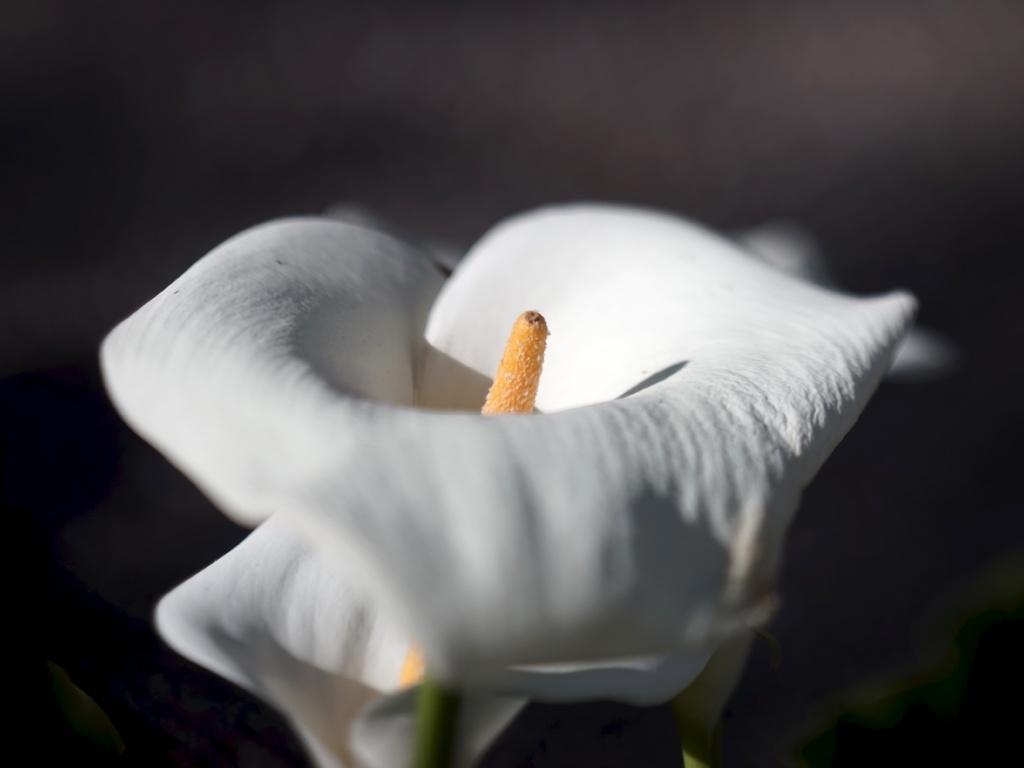How would you summarize this image in a sentence or two? In this picture I can see flowers, and there is blur background. 